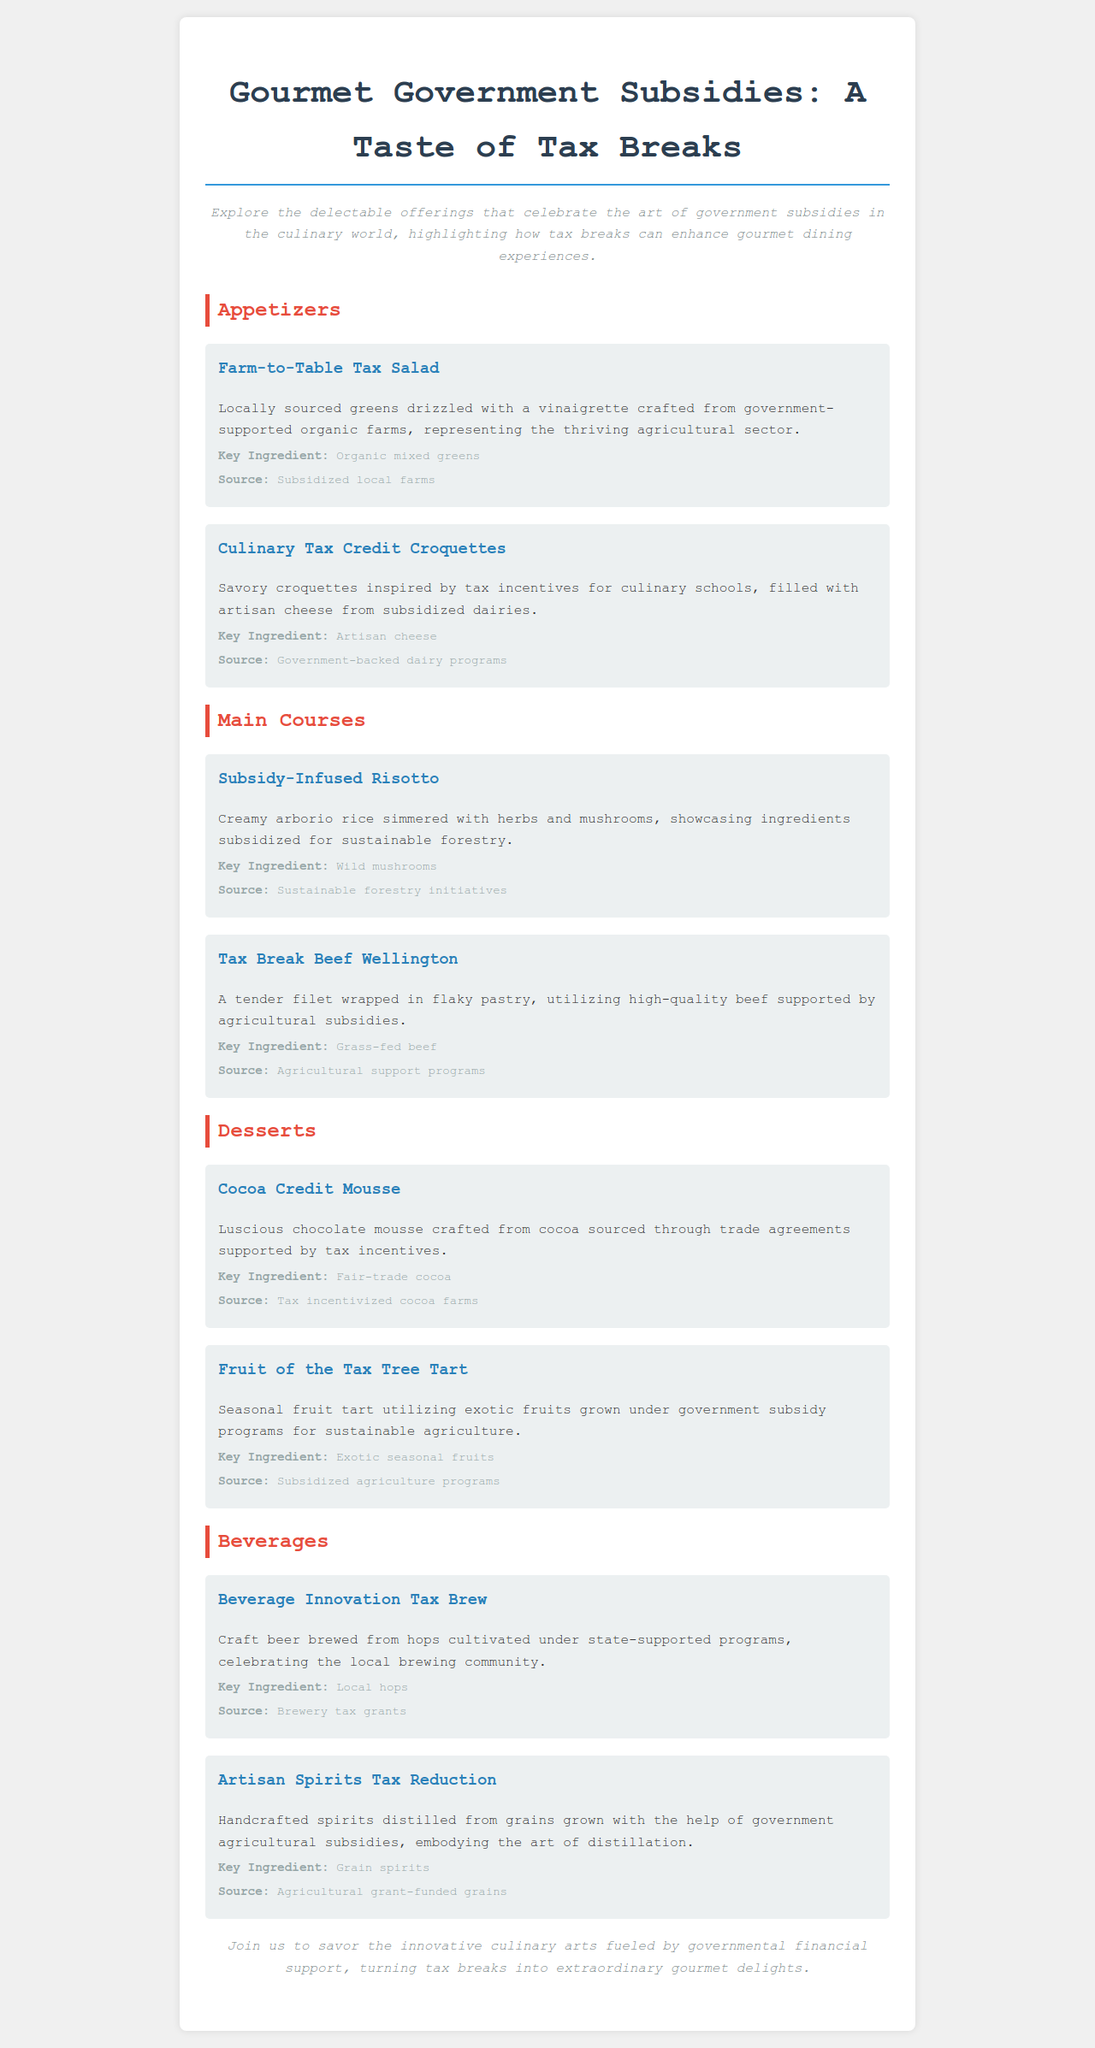What is the title of the document? The title is prominently displayed at the top of the document.
Answer: Gourmet Government Subsidies: A Taste of Tax Breaks How many appetizers are listed on the menu? The number of appetizers can be found by counting the items under the Appetizers section.
Answer: 2 What is the main ingredient in the Tax Break Beef Wellington? The main ingredient is specified in the description of the menu item.
Answer: Grass-fed beef Which beverage uses locally sourced hops? The name of the beverage is provided in the Beverages section.
Answer: Beverage Innovation Tax Brew What type of fruits are used in the Fruit of the Tax Tree Tart? The type of fruits is mentioned in the description of the dessert.
Answer: Exotic seasonal fruits Which menu item represents government-supported organic farms? The item description indicates its connection to government support.
Answer: Farm-to-Table Tax Salad What is the source of the artisan cheese used in the Culinary Tax Credit Croquettes? The source is indicated in the menu item details.
Answer: Government-backed dairy programs Which dessert is crafted from tax incentivized cocoa farms? The dessert's description highlights the source of its ingredients.
Answer: Cocoa Credit Mousse 